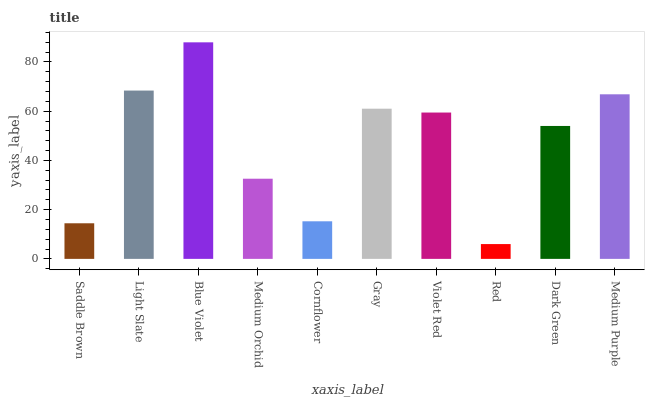Is Red the minimum?
Answer yes or no. Yes. Is Blue Violet the maximum?
Answer yes or no. Yes. Is Light Slate the minimum?
Answer yes or no. No. Is Light Slate the maximum?
Answer yes or no. No. Is Light Slate greater than Saddle Brown?
Answer yes or no. Yes. Is Saddle Brown less than Light Slate?
Answer yes or no. Yes. Is Saddle Brown greater than Light Slate?
Answer yes or no. No. Is Light Slate less than Saddle Brown?
Answer yes or no. No. Is Violet Red the high median?
Answer yes or no. Yes. Is Dark Green the low median?
Answer yes or no. Yes. Is Medium Orchid the high median?
Answer yes or no. No. Is Blue Violet the low median?
Answer yes or no. No. 